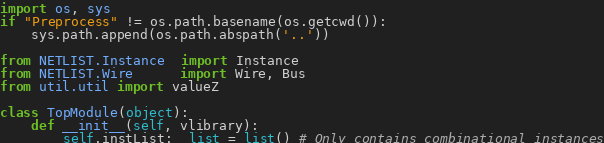Convert code to text. <code><loc_0><loc_0><loc_500><loc_500><_Python_>import os, sys
if "Preprocess" != os.path.basename(os.getcwd()):
    sys.path.append(os.path.abspath('..'))

from NETLIST.Instance  import Instance
from NETLIST.Wire      import Wire, Bus
from util.util import valueZ

class TopModule(object):
    def __init__(self, vlibrary):
        self.instList:  list = list() # Only contains combinational instances</code> 